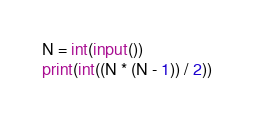<code> <loc_0><loc_0><loc_500><loc_500><_Python_>N = int(input())
print(int((N * (N - 1)) / 2))</code> 